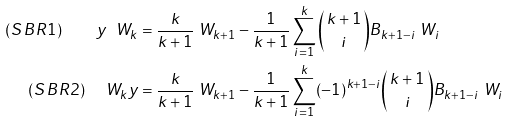<formula> <loc_0><loc_0><loc_500><loc_500>( S \, B R 1 ) \quad y \ W _ { k } & = \frac { k } { k + 1 } \ W _ { k + 1 } - \frac { 1 } { k + 1 } \sum _ { i = 1 } ^ { k } \binom { \, k + 1 \, } { i } B _ { k + 1 - i } \ W _ { i } \\ ( S \, B R 2 ) \quad \ W _ { k } y & = \frac { k } { k + 1 } \ W _ { k + 1 } - \frac { 1 } { k + 1 } \sum _ { i = 1 } ^ { k } ( - 1 ) ^ { k + 1 - i } \binom { \, k + 1 \, } { i } B _ { k + 1 - i } \ W _ { i } \\</formula> 